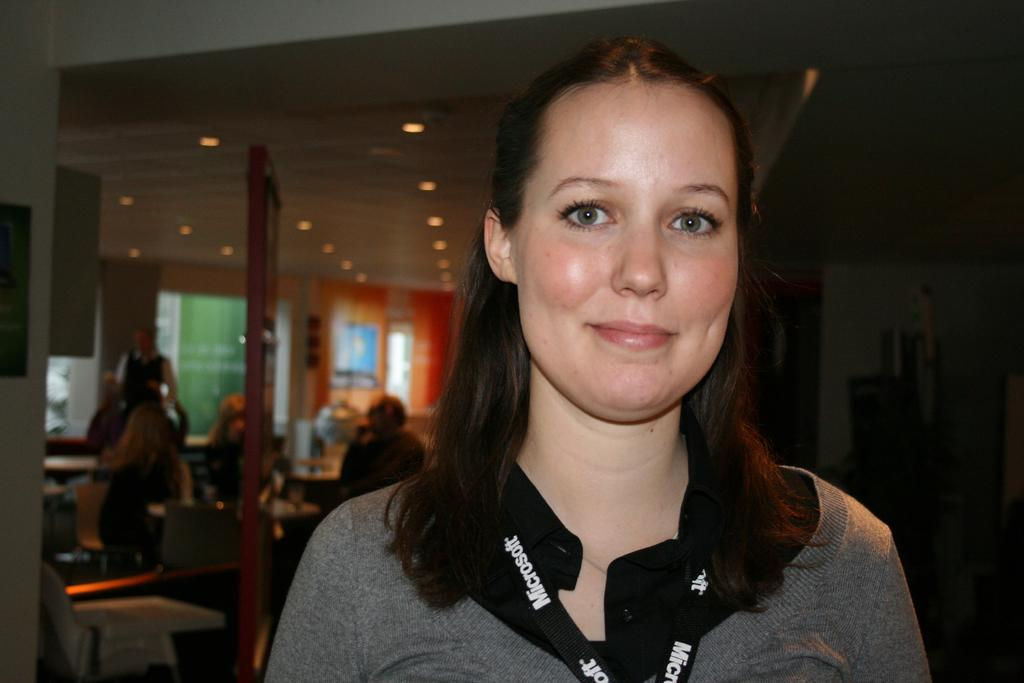<image>
Create a compact narrative representing the image presented. A woman is wearing a Microsoft lanyard and smiling. 